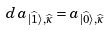<formula> <loc_0><loc_0><loc_500><loc_500>d \, a _ { | \widehat { 1 } \rangle , \widehat { \kappa } } = a _ { | \widehat { 0 } \rangle , \widehat { \kappa } }</formula> 